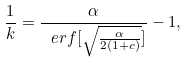Convert formula to latex. <formula><loc_0><loc_0><loc_500><loc_500>\frac { 1 } { k } = \frac { \alpha } { \ e r f [ \sqrt { \frac { \alpha } { 2 ( 1 + c ) } } ] } - 1 ,</formula> 